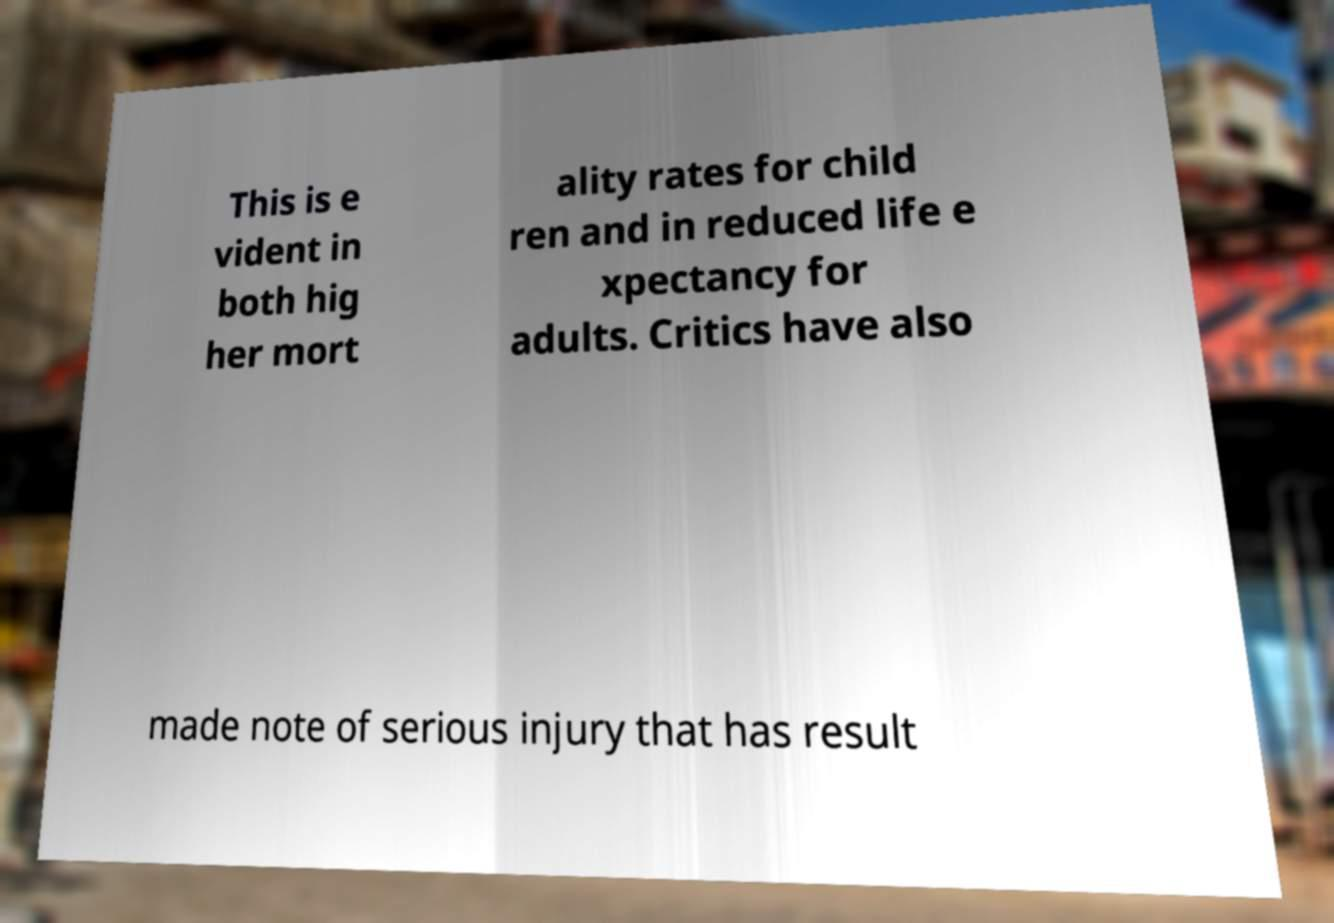There's text embedded in this image that I need extracted. Can you transcribe it verbatim? This is e vident in both hig her mort ality rates for child ren and in reduced life e xpectancy for adults. Critics have also made note of serious injury that has result 